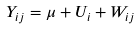Convert formula to latex. <formula><loc_0><loc_0><loc_500><loc_500>Y _ { i j } = \mu + U _ { i } + W _ { i j }</formula> 